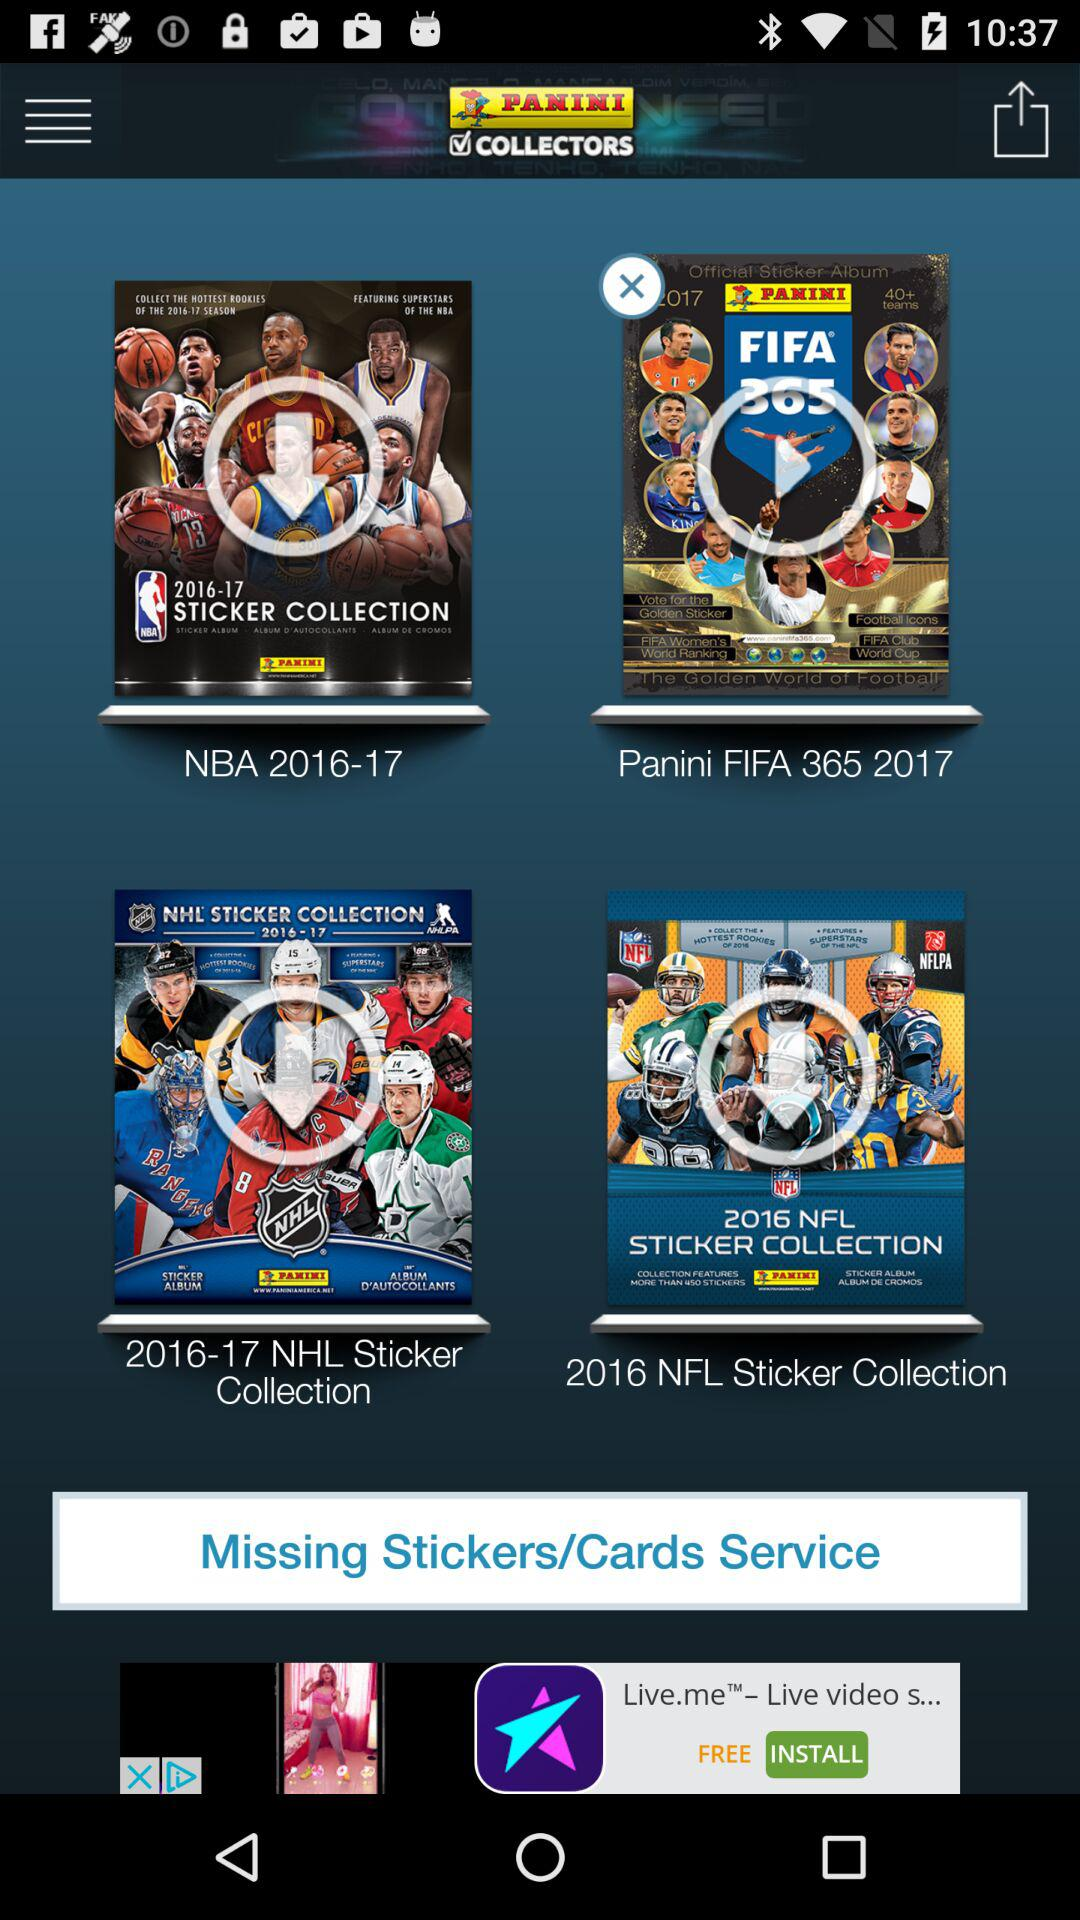What is the year of "NHL Sticker Collection"? The year is 2016-17. 